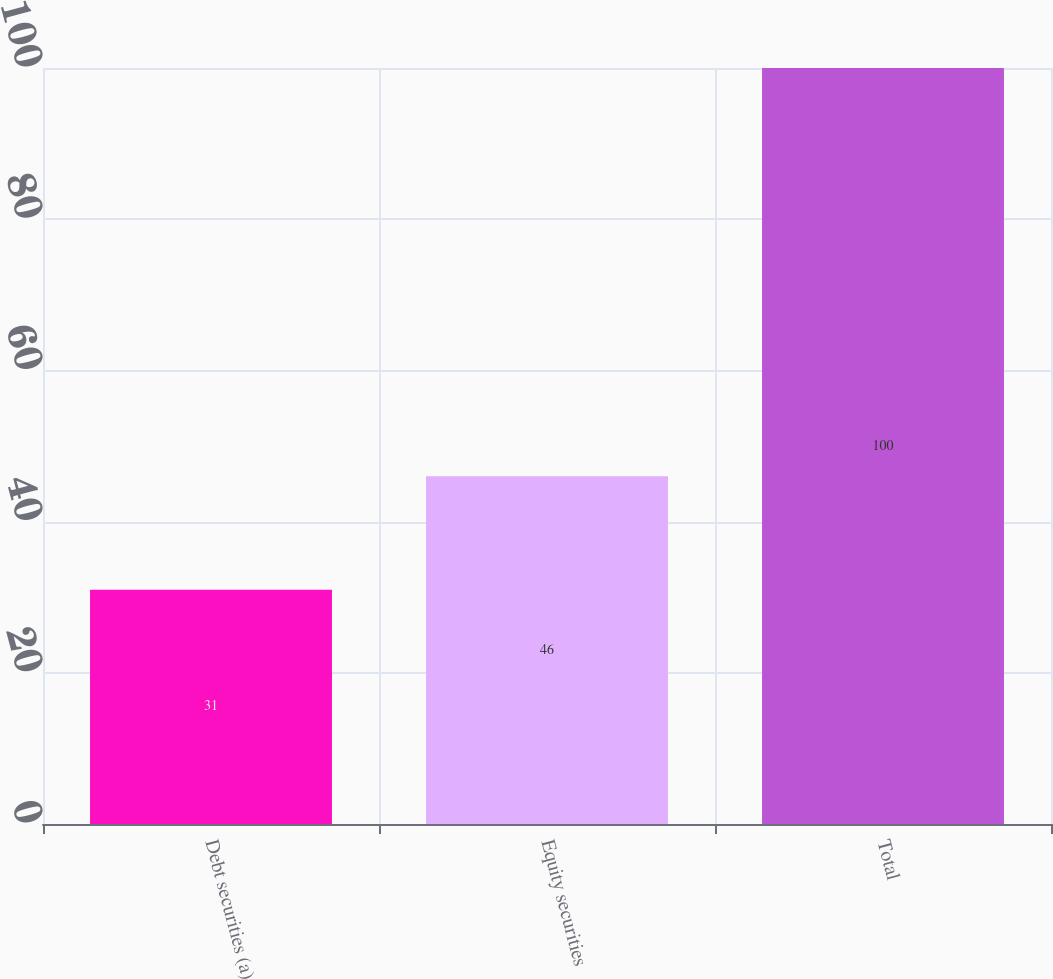Convert chart to OTSL. <chart><loc_0><loc_0><loc_500><loc_500><bar_chart><fcel>Debt securities (a)<fcel>Equity securities<fcel>Total<nl><fcel>31<fcel>46<fcel>100<nl></chart> 